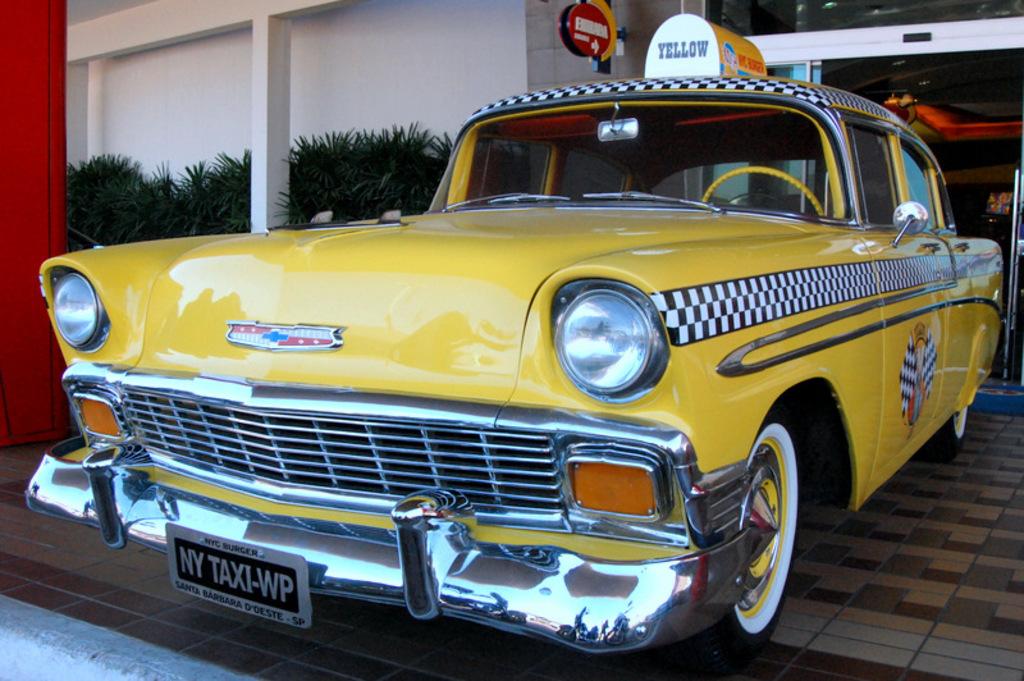Is this taxi from ny?
Ensure brevity in your answer.  Yes. What collor is writte on the top of the cab?
Your answer should be very brief. Yellow. 